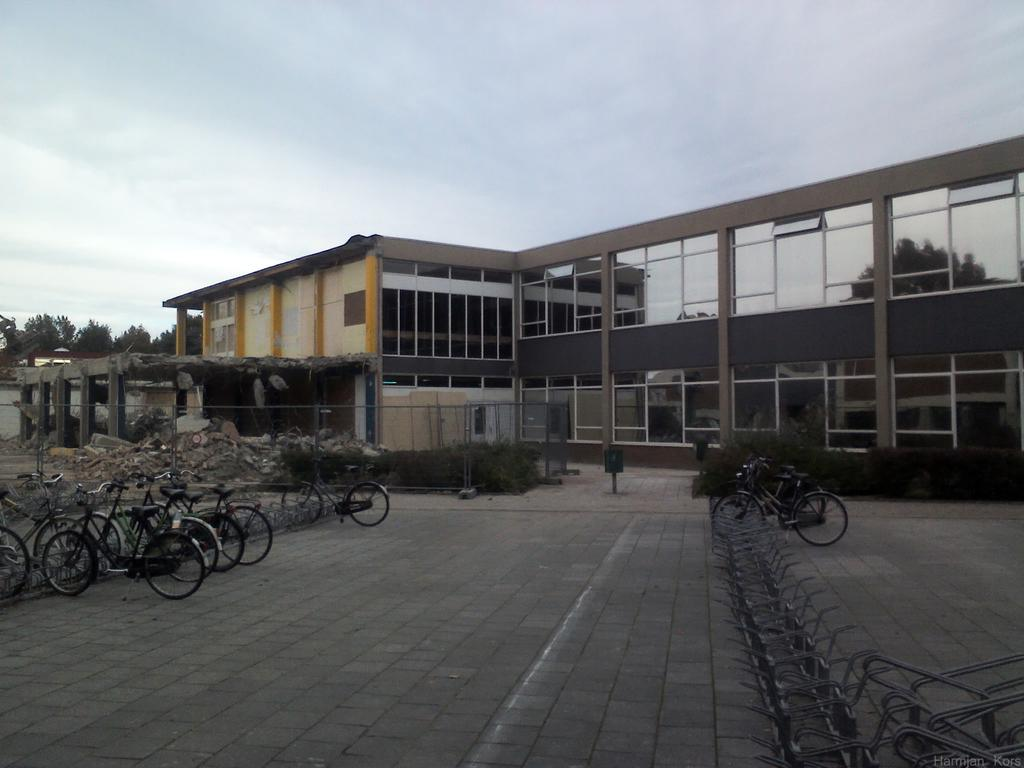What type of structure is present in the image? There is a building in the image. What can be seen near the building? There are bicycles parked and trees in the image. What type of barrier is present in the image? There is a metal fence in the image. What type of vegetation is present in the image? There are plants in the image. What is the condition of the sky in the image? The sky is cloudy in the image. Are there any other structures present in the image? Yes, there is a dismantled building in the image. What type of shop can be seen in the image? There is no shop present in the image. What shape is the square in the image? There is no square present in the image. 